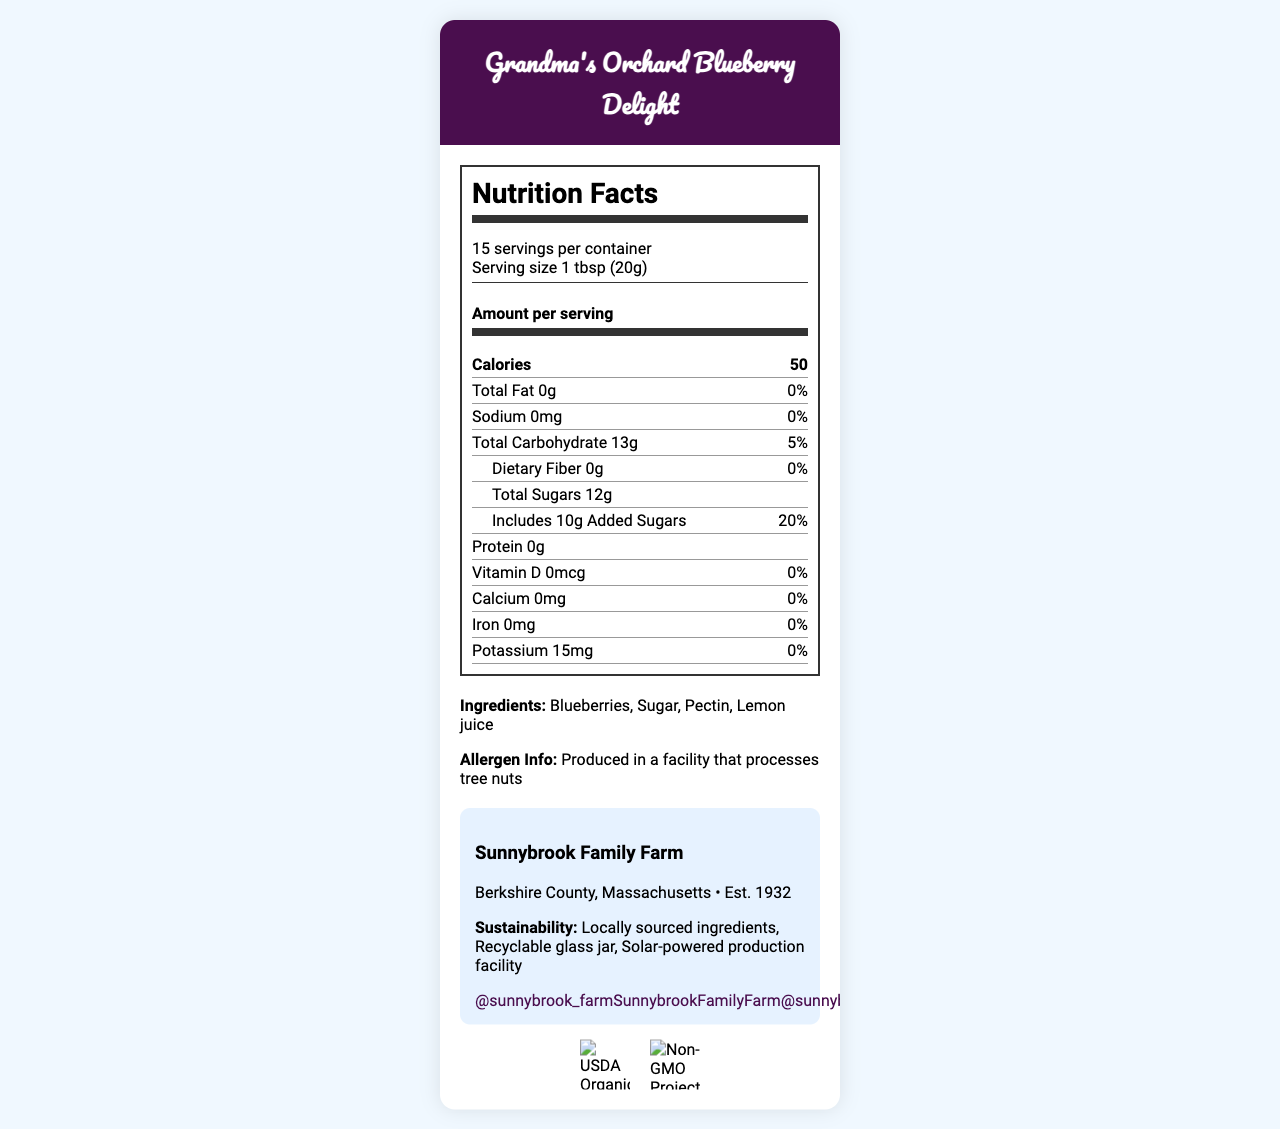what is the serving size for Grandma's Orchard Blueberry Delight? The serving size is explicitly mentioned as "1 tbsp (20g)" in the document under the Nutrition Facts section.
Answer: 1 tbsp (20g) how many servings are there per container? The document states there are "15 servings per container" in the Nutrition Facts section.
Answer: 15 how many calories are there per serving? The document indicates that there are "50 calories" per serving under the Amount per Serving section.
Answer: 50 list the ingredients used in the fruit preserve. The ingredients are listed under the Ingredients section in bold within the document.
Answer: Blueberries, Sugar, Pectin, Lemon juice is there any protein in Grandma's Orchard Blueberry Delight? The document states there is "0g" of protein in the Nutrition Facts section.
Answer: No what is the color of the lid on the jar? The description under instagram_worthy_elements mentions the lid color is "Rose gold".
Answer: Rose gold which of the following ingredients is used in Grandma's Orchard Blueberry Delight? A. Raspberries B. Strawberries C. Blueberries The document lists "Blueberries" as one of the ingredients in the Ingredients section.
Answer: C. Blueberries what is the daily value percentage of total fat? A. 0% B. 5% C. 10% The document shows "0%" daily value for total fat in the Nutrition Facts section.
Answer: A. 0% based on the document, is the product suitable for someone avoiding sodium? The document lists "Sodium 0mg" and "0%" daily value, indicating there is no sodium in the product.
Answer: Yes describe the main design elements of the packaging. The document details multiple design elements including the hexagonal jar, rose gold lid, watercolor blueberry pattern, and other features under instagram_worthy_elements.
Answer: Hexagonal jar with rose gold lid, watercolor blueberry pattern, hand-drawn script font, navy blue, lavender, and white color scheme, twine bow around the jar neck, mini wooden spoon attached, QR code for recipes. are all the ingredients used in the preserve organic? The document states certifications like "USDA Organic", but it does not specify which exact ingredients are organic.
Answer: Cannot be determined 